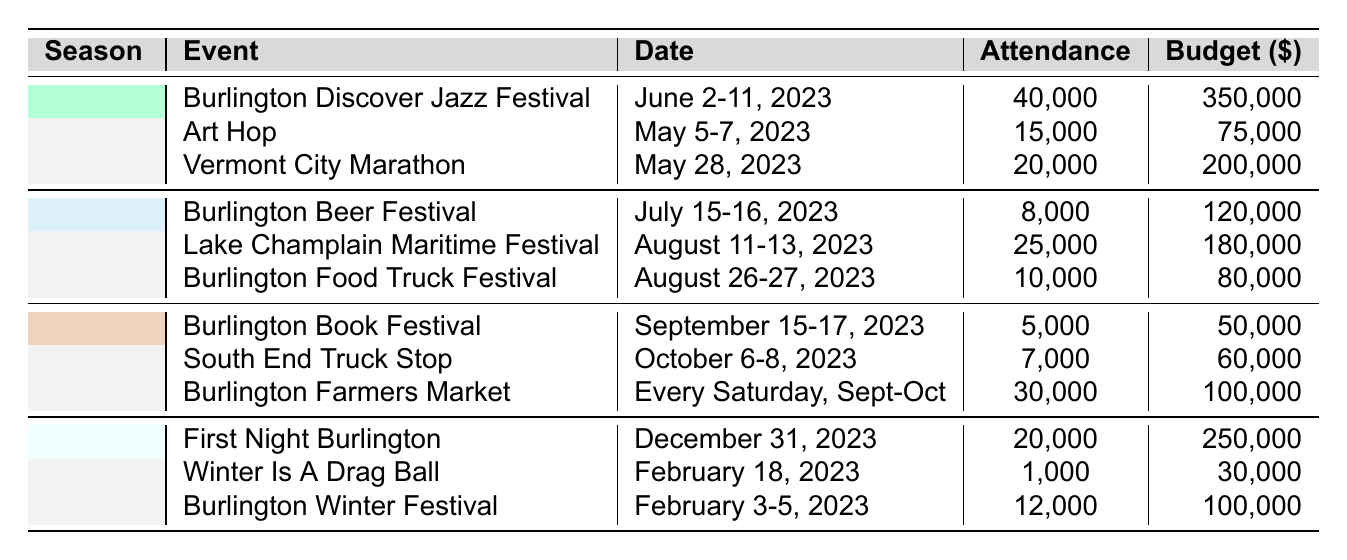What is the total attendance for the Burlington Discover Jazz Festival? The table shows the attendance for the Burlington Discover Jazz Festival is 40,000.
Answer: 40,000 What is the budget for the Burlington Food Truck Festival? According to the table, the budget allocated for the Burlington Food Truck Festival is $80,000.
Answer: $80,000 Which event had the highest attendance in the spring season? The Burlington Discover Jazz Festival had the highest attendance in the spring season at 40,000 people.
Answer: Burlington Discover Jazz Festival What is the total budget allocation for all events in the summer? The total budget for the summer events is calculated as follows: Burlington Beer Festival ($120,000) + Lake Champlain Maritime Festival ($180,000) + Burlington Food Truck Festival ($80,000) = $380,000.
Answer: $380,000 How many events are scheduled in the fall season? There are three events listed for the fall season: Burlington Book Festival, South End Truck Stop, and Burlington Farmers Market.
Answer: 3 Is the attendance for the Winter Is A Drag Ball greater than that for the Burlington Book Festival? The attendance for the Winter Is A Drag Ball is 1,000, while the attendance for the Burlington Book Festival is 5,000. Since 1,000 is less than 5,000, the answer is no.
Answer: No What is the average attendance for the summer events? The attendance for summer events is: Burlington Beer Festival (8,000), Lake Champlain Maritime Festival (25,000), and Burlington Food Truck Festival (10,000). The total attendance is 8,000 + 25,000 + 10,000 = 43,000. Dividing by the number of events (3) gives an average of 43,000 / 3 = 14,333.
Answer: 14,333 Which season has the lowest total budget allocation, and what is that amount? The fall season budgets total: Burlington Book Festival ($50,000) + South End Truck Stop ($60,000) + Burlington Farmers Market ($100,000) = $210,000. The winter season totals: First Night Burlington ($250,000) + Winter Is A Drag Ball ($30,000) + Burlington Winter Festival ($100,000) = $380,000. The spring season budgets sum to $625,000, and summer totals $380,000. So, the fall has the lowest budget allocation of $210,000.
Answer: Fall, $210,000 How many more people attended the Burlington Discover Jazz Festival compared to the Burlington Book Festival? The attendance for the Burlington Discover Jazz Festival is 40,000 and for the Burlington Book Festival is 5,000. The difference in attendance is 40,000 - 5,000 = 35,000.
Answer: 35,000 Was the budget for the First Night Burlington event higher than the combined budget for the other winter events? The budget for First Night Burlington is $250,000 while the combined budget for Winter Is A Drag Ball ($30,000) and Burlington Winter Festival ($100,000) is $130,000. Since $250,000 is greater than $130,000, the answer is yes.
Answer: Yes 